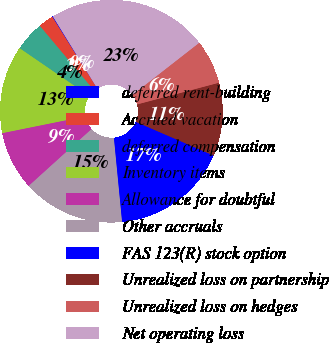Convert chart to OTSL. <chart><loc_0><loc_0><loc_500><loc_500><pie_chart><fcel>deferred rent-building<fcel>Accrued vacation<fcel>deferred compensation<fcel>Inventory items<fcel>Allowance for doubtful<fcel>Other accruals<fcel>FAS 123(R) stock option<fcel>Unrealized loss on partnership<fcel>Unrealized loss on hedges<fcel>Net operating loss<nl><fcel>0.11%<fcel>2.21%<fcel>4.32%<fcel>12.74%<fcel>8.53%<fcel>14.84%<fcel>16.95%<fcel>10.63%<fcel>6.42%<fcel>23.26%<nl></chart> 